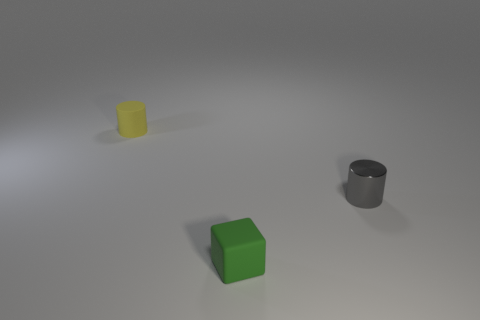Are there any green things that have the same size as the gray cylinder?
Provide a succinct answer. Yes. There is a cylinder that is on the right side of the green thing; what size is it?
Your answer should be compact. Small. What color is the small cylinder that is right of the object that is behind the cylinder in front of the small yellow object?
Keep it short and to the point. Gray. There is a cylinder that is to the right of the yellow matte cylinder behind the tiny gray metallic cylinder; what color is it?
Ensure brevity in your answer.  Gray. Are there more yellow cylinders on the left side of the tiny yellow rubber cylinder than small rubber things that are to the right of the tiny gray metal cylinder?
Your response must be concise. No. Are the tiny thing on the left side of the tiny green block and the small cylinder that is in front of the tiny rubber cylinder made of the same material?
Your answer should be compact. No. Are there any tiny yellow cylinders right of the rubber cylinder?
Ensure brevity in your answer.  No. What number of red objects are either tiny shiny cylinders or cylinders?
Your answer should be very brief. 0. Do the tiny green object and the tiny gray object that is in front of the tiny yellow cylinder have the same material?
Offer a very short reply. No. What is the size of the yellow rubber object that is the same shape as the gray metal object?
Keep it short and to the point. Small. 